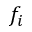Convert formula to latex. <formula><loc_0><loc_0><loc_500><loc_500>f _ { i }</formula> 